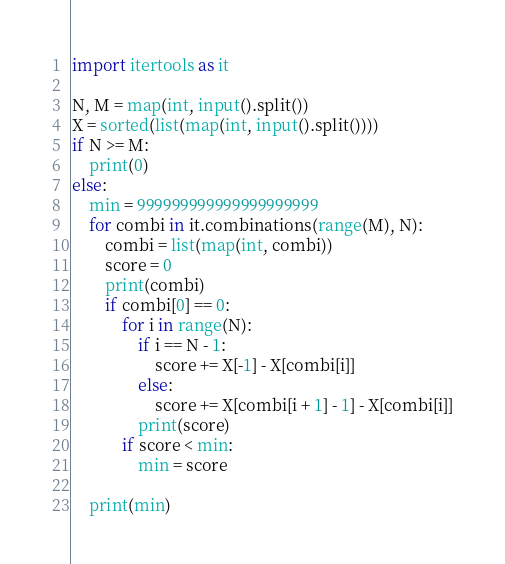Convert code to text. <code><loc_0><loc_0><loc_500><loc_500><_Python_>import itertools as it

N, M = map(int, input().split())
X = sorted(list(map(int, input().split())))
if N >= M:
	print(0)
else:
	min = 999999999999999999999
	for combi in it.combinations(range(M), N):
		combi = list(map(int, combi))
		score = 0
		print(combi)
		if combi[0] == 0:
			for i in range(N):
				if i == N - 1:
					score += X[-1] - X[combi[i]]
				else:
					score += X[combi[i + 1] - 1] - X[combi[i]]
				print(score)
			if score < min:
				min = score
			
	print(min)</code> 